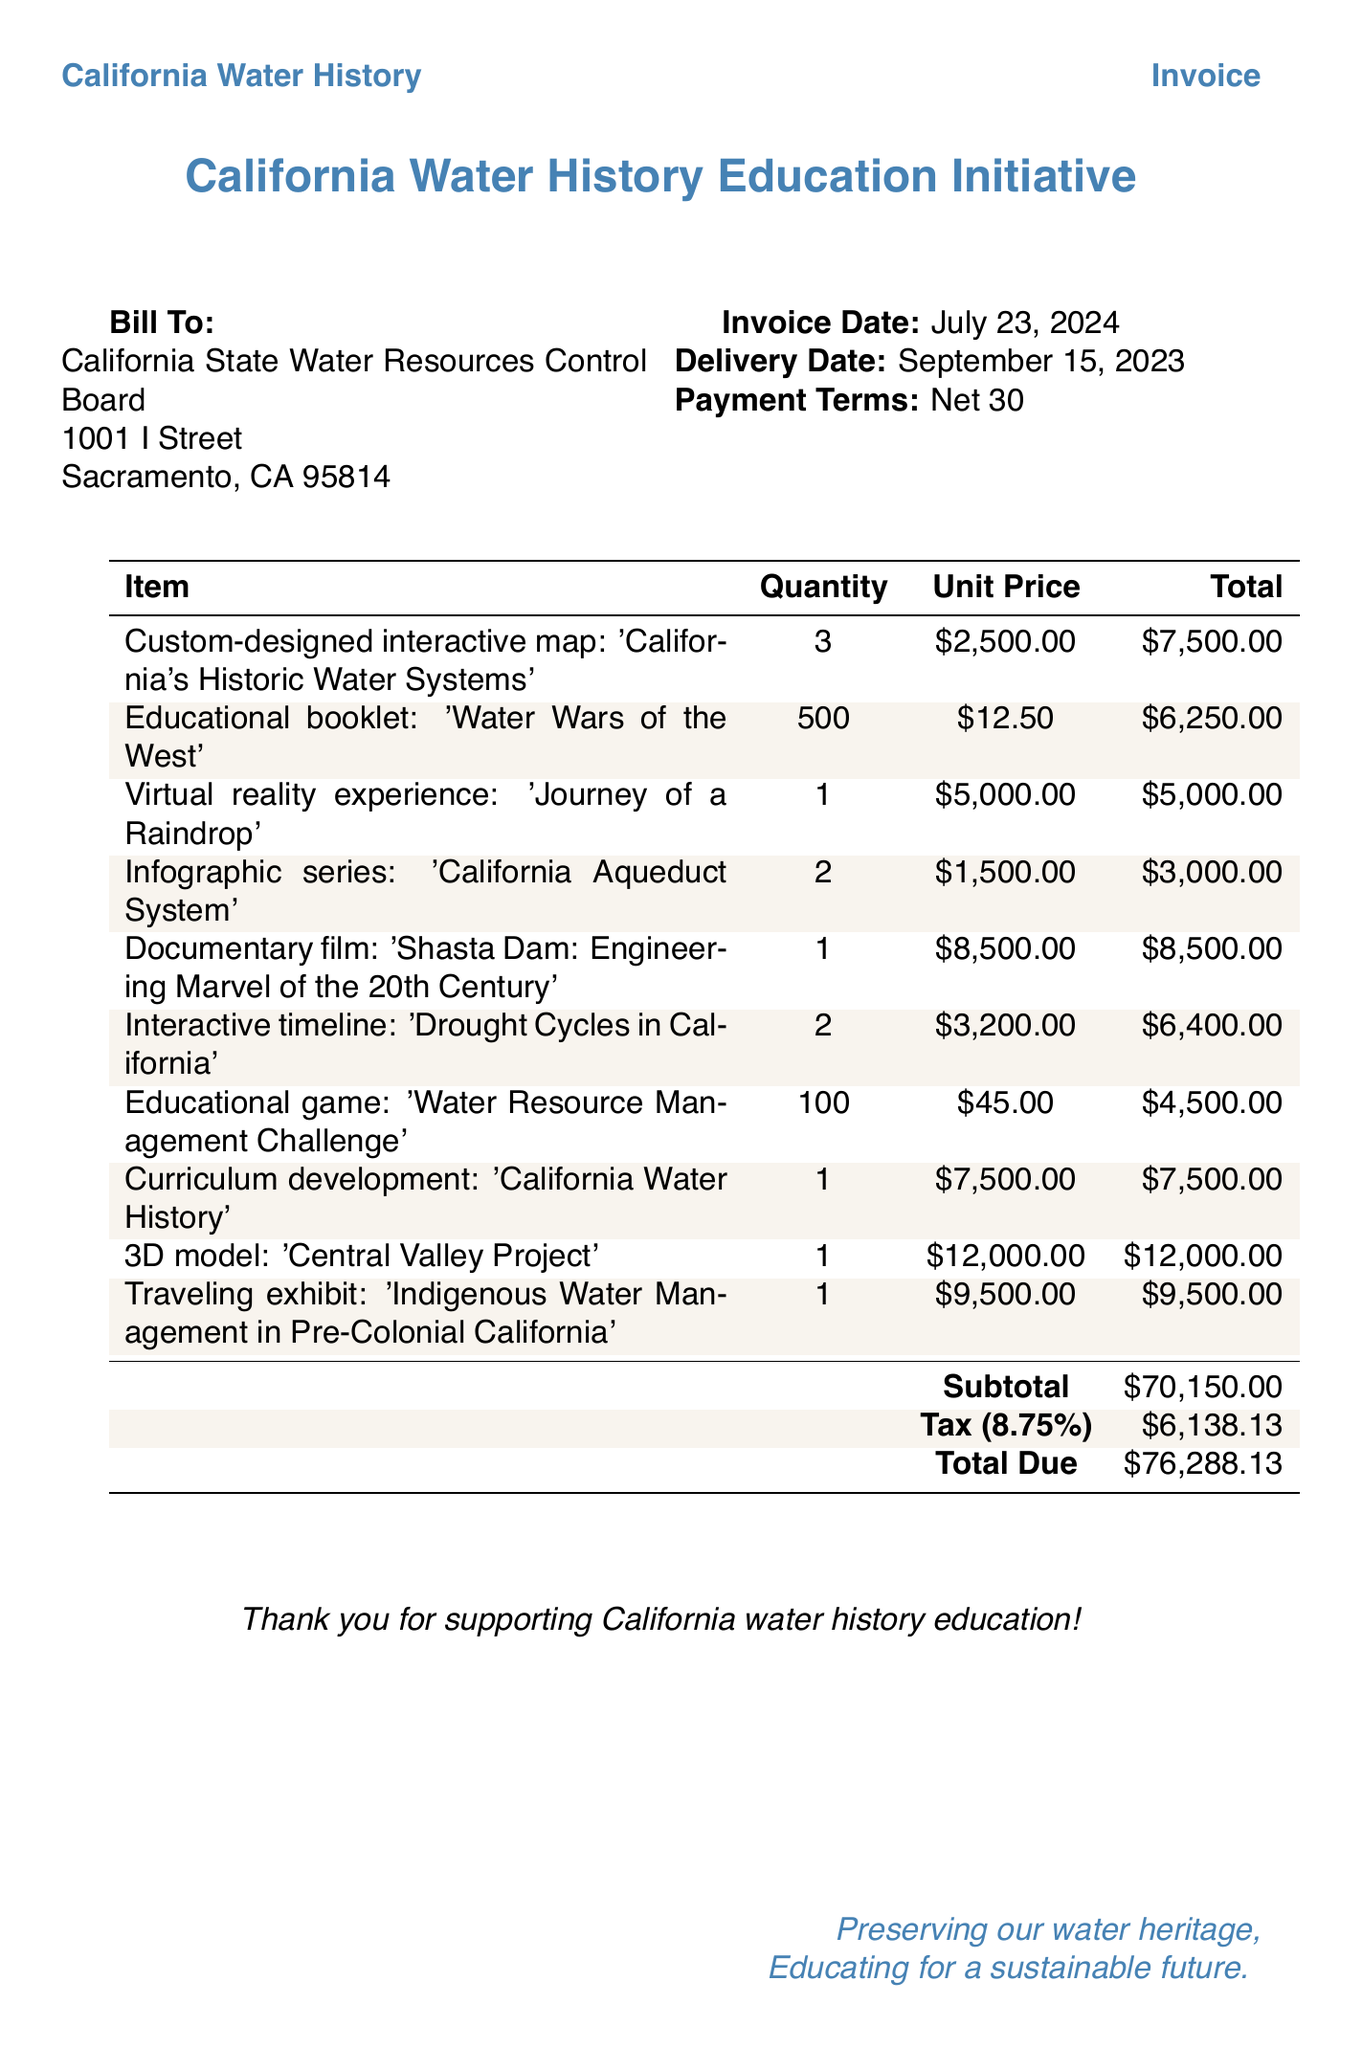What is the subtotal amount? The subtotal amount is listed in the document before tax, specifically noted as $70,150.00.
Answer: $70,150.00 Who is the client? The document identifies the client by name, which is the California State Water Resources Control Board.
Answer: California State Water Resources Control Board What is the payment term? The document specifies the payment terms clearly under the payment terms section as “Net 30”.
Answer: Net 30 How many items are included in the invoice? By counting the invoice items listed in the table, there are a total of 10 items.
Answer: 10 What is the delivery date? The delivery date mentioned in the document is specified clearly as September 15, 2023.
Answer: September 15, 2023 What is the tax amount? The tax amount is calculated and specified towards the end of the document, shown as $6,138.13.
Answer: $6,138.13 Which item has the highest total price? The item with the highest total price is the 3D model of the Central Valley Project, which costs $12,000.00.
Answer: $12,000.00 What is the total due amount? The total due amount is prominently displayed in the document, calculated as $76,288.13.
Answer: $76,288.13 